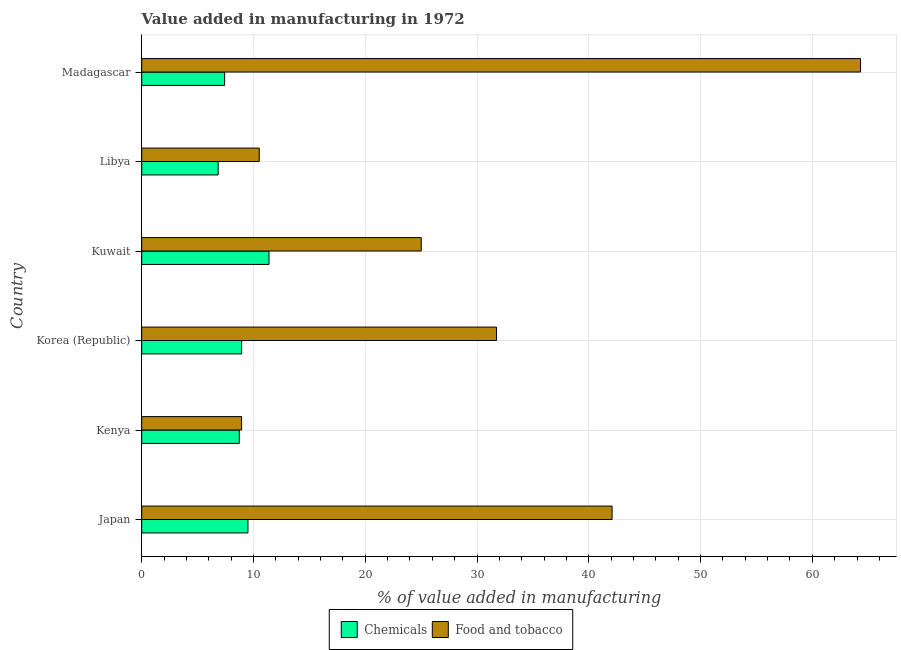How many different coloured bars are there?
Offer a very short reply. 2. How many bars are there on the 3rd tick from the top?
Keep it short and to the point. 2. What is the label of the 4th group of bars from the top?
Ensure brevity in your answer.  Korea (Republic). What is the value added by manufacturing food and tobacco in Kenya?
Keep it short and to the point. 8.94. Across all countries, what is the maximum value added by manufacturing food and tobacco?
Your response must be concise. 64.31. Across all countries, what is the minimum value added by  manufacturing chemicals?
Make the answer very short. 6.84. In which country was the value added by manufacturing food and tobacco maximum?
Ensure brevity in your answer.  Madagascar. In which country was the value added by  manufacturing chemicals minimum?
Offer a terse response. Libya. What is the total value added by manufacturing food and tobacco in the graph?
Provide a short and direct response. 182.6. What is the difference between the value added by manufacturing food and tobacco in Japan and that in Kuwait?
Keep it short and to the point. 17.07. What is the difference between the value added by  manufacturing chemicals in Libya and the value added by manufacturing food and tobacco in Korea (Republic)?
Ensure brevity in your answer.  -24.91. What is the average value added by manufacturing food and tobacco per country?
Keep it short and to the point. 30.43. What is the difference between the value added by manufacturing food and tobacco and value added by  manufacturing chemicals in Libya?
Provide a succinct answer. 3.68. In how many countries, is the value added by  manufacturing chemicals greater than 12 %?
Keep it short and to the point. 0. What is the ratio of the value added by  manufacturing chemicals in Japan to that in Korea (Republic)?
Offer a very short reply. 1.06. Is the difference between the value added by manufacturing food and tobacco in Korea (Republic) and Libya greater than the difference between the value added by  manufacturing chemicals in Korea (Republic) and Libya?
Give a very brief answer. Yes. What is the difference between the highest and the second highest value added by  manufacturing chemicals?
Ensure brevity in your answer.  1.88. What is the difference between the highest and the lowest value added by  manufacturing chemicals?
Provide a short and direct response. 4.55. In how many countries, is the value added by  manufacturing chemicals greater than the average value added by  manufacturing chemicals taken over all countries?
Make the answer very short. 3. What does the 1st bar from the top in Japan represents?
Offer a very short reply. Food and tobacco. What does the 1st bar from the bottom in Libya represents?
Offer a terse response. Chemicals. How many bars are there?
Your response must be concise. 12. How many countries are there in the graph?
Offer a terse response. 6. Are the values on the major ticks of X-axis written in scientific E-notation?
Keep it short and to the point. No. Does the graph contain any zero values?
Provide a succinct answer. No. What is the title of the graph?
Your response must be concise. Value added in manufacturing in 1972. Does "Nonresident" appear as one of the legend labels in the graph?
Keep it short and to the point. No. What is the label or title of the X-axis?
Your response must be concise. % of value added in manufacturing. What is the label or title of the Y-axis?
Make the answer very short. Country. What is the % of value added in manufacturing of Chemicals in Japan?
Your answer should be compact. 9.5. What is the % of value added in manufacturing of Food and tobacco in Japan?
Offer a very short reply. 42.08. What is the % of value added in manufacturing of Chemicals in Kenya?
Your answer should be very brief. 8.73. What is the % of value added in manufacturing of Food and tobacco in Kenya?
Give a very brief answer. 8.94. What is the % of value added in manufacturing in Chemicals in Korea (Republic)?
Provide a succinct answer. 8.94. What is the % of value added in manufacturing of Food and tobacco in Korea (Republic)?
Provide a succinct answer. 31.75. What is the % of value added in manufacturing in Chemicals in Kuwait?
Your answer should be compact. 11.39. What is the % of value added in manufacturing of Food and tobacco in Kuwait?
Offer a terse response. 25.01. What is the % of value added in manufacturing of Chemicals in Libya?
Offer a very short reply. 6.84. What is the % of value added in manufacturing of Food and tobacco in Libya?
Your answer should be compact. 10.51. What is the % of value added in manufacturing of Chemicals in Madagascar?
Provide a short and direct response. 7.42. What is the % of value added in manufacturing in Food and tobacco in Madagascar?
Offer a terse response. 64.31. Across all countries, what is the maximum % of value added in manufacturing in Chemicals?
Your answer should be compact. 11.39. Across all countries, what is the maximum % of value added in manufacturing in Food and tobacco?
Offer a terse response. 64.31. Across all countries, what is the minimum % of value added in manufacturing of Chemicals?
Offer a very short reply. 6.84. Across all countries, what is the minimum % of value added in manufacturing of Food and tobacco?
Keep it short and to the point. 8.94. What is the total % of value added in manufacturing of Chemicals in the graph?
Offer a terse response. 52.82. What is the total % of value added in manufacturing in Food and tobacco in the graph?
Give a very brief answer. 182.6. What is the difference between the % of value added in manufacturing of Chemicals in Japan and that in Kenya?
Keep it short and to the point. 0.77. What is the difference between the % of value added in manufacturing in Food and tobacco in Japan and that in Kenya?
Give a very brief answer. 33.15. What is the difference between the % of value added in manufacturing of Chemicals in Japan and that in Korea (Republic)?
Keep it short and to the point. 0.56. What is the difference between the % of value added in manufacturing in Food and tobacco in Japan and that in Korea (Republic)?
Provide a succinct answer. 10.34. What is the difference between the % of value added in manufacturing of Chemicals in Japan and that in Kuwait?
Ensure brevity in your answer.  -1.88. What is the difference between the % of value added in manufacturing in Food and tobacco in Japan and that in Kuwait?
Your answer should be very brief. 17.07. What is the difference between the % of value added in manufacturing of Chemicals in Japan and that in Libya?
Ensure brevity in your answer.  2.67. What is the difference between the % of value added in manufacturing of Food and tobacco in Japan and that in Libya?
Provide a succinct answer. 31.57. What is the difference between the % of value added in manufacturing in Chemicals in Japan and that in Madagascar?
Your answer should be very brief. 2.08. What is the difference between the % of value added in manufacturing in Food and tobacco in Japan and that in Madagascar?
Your answer should be very brief. -22.23. What is the difference between the % of value added in manufacturing of Chemicals in Kenya and that in Korea (Republic)?
Make the answer very short. -0.21. What is the difference between the % of value added in manufacturing in Food and tobacco in Kenya and that in Korea (Republic)?
Ensure brevity in your answer.  -22.81. What is the difference between the % of value added in manufacturing of Chemicals in Kenya and that in Kuwait?
Provide a short and direct response. -2.66. What is the difference between the % of value added in manufacturing in Food and tobacco in Kenya and that in Kuwait?
Offer a very short reply. -16.07. What is the difference between the % of value added in manufacturing in Chemicals in Kenya and that in Libya?
Provide a succinct answer. 1.89. What is the difference between the % of value added in manufacturing in Food and tobacco in Kenya and that in Libya?
Your answer should be very brief. -1.58. What is the difference between the % of value added in manufacturing in Chemicals in Kenya and that in Madagascar?
Your response must be concise. 1.31. What is the difference between the % of value added in manufacturing in Food and tobacco in Kenya and that in Madagascar?
Offer a very short reply. -55.38. What is the difference between the % of value added in manufacturing in Chemicals in Korea (Republic) and that in Kuwait?
Offer a terse response. -2.45. What is the difference between the % of value added in manufacturing of Food and tobacco in Korea (Republic) and that in Kuwait?
Your answer should be very brief. 6.74. What is the difference between the % of value added in manufacturing in Chemicals in Korea (Republic) and that in Libya?
Give a very brief answer. 2.1. What is the difference between the % of value added in manufacturing of Food and tobacco in Korea (Republic) and that in Libya?
Offer a terse response. 21.23. What is the difference between the % of value added in manufacturing in Chemicals in Korea (Republic) and that in Madagascar?
Keep it short and to the point. 1.52. What is the difference between the % of value added in manufacturing of Food and tobacco in Korea (Republic) and that in Madagascar?
Make the answer very short. -32.57. What is the difference between the % of value added in manufacturing of Chemicals in Kuwait and that in Libya?
Your answer should be compact. 4.55. What is the difference between the % of value added in manufacturing of Food and tobacco in Kuwait and that in Libya?
Make the answer very short. 14.49. What is the difference between the % of value added in manufacturing in Chemicals in Kuwait and that in Madagascar?
Ensure brevity in your answer.  3.97. What is the difference between the % of value added in manufacturing of Food and tobacco in Kuwait and that in Madagascar?
Your response must be concise. -39.3. What is the difference between the % of value added in manufacturing in Chemicals in Libya and that in Madagascar?
Provide a short and direct response. -0.58. What is the difference between the % of value added in manufacturing in Food and tobacco in Libya and that in Madagascar?
Make the answer very short. -53.8. What is the difference between the % of value added in manufacturing of Chemicals in Japan and the % of value added in manufacturing of Food and tobacco in Kenya?
Provide a short and direct response. 0.57. What is the difference between the % of value added in manufacturing in Chemicals in Japan and the % of value added in manufacturing in Food and tobacco in Korea (Republic)?
Ensure brevity in your answer.  -22.24. What is the difference between the % of value added in manufacturing of Chemicals in Japan and the % of value added in manufacturing of Food and tobacco in Kuwait?
Provide a succinct answer. -15.5. What is the difference between the % of value added in manufacturing of Chemicals in Japan and the % of value added in manufacturing of Food and tobacco in Libya?
Make the answer very short. -1.01. What is the difference between the % of value added in manufacturing in Chemicals in Japan and the % of value added in manufacturing in Food and tobacco in Madagascar?
Make the answer very short. -54.81. What is the difference between the % of value added in manufacturing of Chemicals in Kenya and the % of value added in manufacturing of Food and tobacco in Korea (Republic)?
Provide a succinct answer. -23.02. What is the difference between the % of value added in manufacturing in Chemicals in Kenya and the % of value added in manufacturing in Food and tobacco in Kuwait?
Provide a short and direct response. -16.28. What is the difference between the % of value added in manufacturing of Chemicals in Kenya and the % of value added in manufacturing of Food and tobacco in Libya?
Offer a terse response. -1.79. What is the difference between the % of value added in manufacturing in Chemicals in Kenya and the % of value added in manufacturing in Food and tobacco in Madagascar?
Your response must be concise. -55.58. What is the difference between the % of value added in manufacturing in Chemicals in Korea (Republic) and the % of value added in manufacturing in Food and tobacco in Kuwait?
Provide a short and direct response. -16.07. What is the difference between the % of value added in manufacturing in Chemicals in Korea (Republic) and the % of value added in manufacturing in Food and tobacco in Libya?
Provide a succinct answer. -1.57. What is the difference between the % of value added in manufacturing in Chemicals in Korea (Republic) and the % of value added in manufacturing in Food and tobacco in Madagascar?
Offer a terse response. -55.37. What is the difference between the % of value added in manufacturing in Chemicals in Kuwait and the % of value added in manufacturing in Food and tobacco in Libya?
Keep it short and to the point. 0.87. What is the difference between the % of value added in manufacturing in Chemicals in Kuwait and the % of value added in manufacturing in Food and tobacco in Madagascar?
Give a very brief answer. -52.93. What is the difference between the % of value added in manufacturing of Chemicals in Libya and the % of value added in manufacturing of Food and tobacco in Madagascar?
Your answer should be compact. -57.47. What is the average % of value added in manufacturing in Chemicals per country?
Offer a terse response. 8.8. What is the average % of value added in manufacturing of Food and tobacco per country?
Keep it short and to the point. 30.43. What is the difference between the % of value added in manufacturing in Chemicals and % of value added in manufacturing in Food and tobacco in Japan?
Offer a terse response. -32.58. What is the difference between the % of value added in manufacturing of Chemicals and % of value added in manufacturing of Food and tobacco in Kenya?
Offer a very short reply. -0.21. What is the difference between the % of value added in manufacturing of Chemicals and % of value added in manufacturing of Food and tobacco in Korea (Republic)?
Your response must be concise. -22.8. What is the difference between the % of value added in manufacturing of Chemicals and % of value added in manufacturing of Food and tobacco in Kuwait?
Your response must be concise. -13.62. What is the difference between the % of value added in manufacturing of Chemicals and % of value added in manufacturing of Food and tobacco in Libya?
Provide a short and direct response. -3.68. What is the difference between the % of value added in manufacturing of Chemicals and % of value added in manufacturing of Food and tobacco in Madagascar?
Your answer should be compact. -56.89. What is the ratio of the % of value added in manufacturing in Chemicals in Japan to that in Kenya?
Offer a very short reply. 1.09. What is the ratio of the % of value added in manufacturing in Food and tobacco in Japan to that in Kenya?
Offer a very short reply. 4.71. What is the ratio of the % of value added in manufacturing of Chemicals in Japan to that in Korea (Republic)?
Your answer should be compact. 1.06. What is the ratio of the % of value added in manufacturing of Food and tobacco in Japan to that in Korea (Republic)?
Provide a short and direct response. 1.33. What is the ratio of the % of value added in manufacturing in Chemicals in Japan to that in Kuwait?
Provide a succinct answer. 0.83. What is the ratio of the % of value added in manufacturing in Food and tobacco in Japan to that in Kuwait?
Make the answer very short. 1.68. What is the ratio of the % of value added in manufacturing in Chemicals in Japan to that in Libya?
Your answer should be compact. 1.39. What is the ratio of the % of value added in manufacturing in Food and tobacco in Japan to that in Libya?
Provide a succinct answer. 4. What is the ratio of the % of value added in manufacturing of Chemicals in Japan to that in Madagascar?
Make the answer very short. 1.28. What is the ratio of the % of value added in manufacturing in Food and tobacco in Japan to that in Madagascar?
Provide a short and direct response. 0.65. What is the ratio of the % of value added in manufacturing of Chemicals in Kenya to that in Korea (Republic)?
Offer a terse response. 0.98. What is the ratio of the % of value added in manufacturing of Food and tobacco in Kenya to that in Korea (Republic)?
Provide a short and direct response. 0.28. What is the ratio of the % of value added in manufacturing in Chemicals in Kenya to that in Kuwait?
Provide a succinct answer. 0.77. What is the ratio of the % of value added in manufacturing of Food and tobacco in Kenya to that in Kuwait?
Provide a succinct answer. 0.36. What is the ratio of the % of value added in manufacturing in Chemicals in Kenya to that in Libya?
Give a very brief answer. 1.28. What is the ratio of the % of value added in manufacturing of Food and tobacco in Kenya to that in Libya?
Your answer should be compact. 0.85. What is the ratio of the % of value added in manufacturing of Chemicals in Kenya to that in Madagascar?
Your answer should be compact. 1.18. What is the ratio of the % of value added in manufacturing in Food and tobacco in Kenya to that in Madagascar?
Your answer should be compact. 0.14. What is the ratio of the % of value added in manufacturing in Chemicals in Korea (Republic) to that in Kuwait?
Give a very brief answer. 0.79. What is the ratio of the % of value added in manufacturing in Food and tobacco in Korea (Republic) to that in Kuwait?
Your answer should be very brief. 1.27. What is the ratio of the % of value added in manufacturing in Chemicals in Korea (Republic) to that in Libya?
Your response must be concise. 1.31. What is the ratio of the % of value added in manufacturing in Food and tobacco in Korea (Republic) to that in Libya?
Your response must be concise. 3.02. What is the ratio of the % of value added in manufacturing of Chemicals in Korea (Republic) to that in Madagascar?
Your answer should be very brief. 1.21. What is the ratio of the % of value added in manufacturing of Food and tobacco in Korea (Republic) to that in Madagascar?
Your response must be concise. 0.49. What is the ratio of the % of value added in manufacturing in Chemicals in Kuwait to that in Libya?
Your answer should be compact. 1.67. What is the ratio of the % of value added in manufacturing of Food and tobacco in Kuwait to that in Libya?
Ensure brevity in your answer.  2.38. What is the ratio of the % of value added in manufacturing in Chemicals in Kuwait to that in Madagascar?
Keep it short and to the point. 1.53. What is the ratio of the % of value added in manufacturing of Food and tobacco in Kuwait to that in Madagascar?
Provide a short and direct response. 0.39. What is the ratio of the % of value added in manufacturing of Chemicals in Libya to that in Madagascar?
Give a very brief answer. 0.92. What is the ratio of the % of value added in manufacturing of Food and tobacco in Libya to that in Madagascar?
Ensure brevity in your answer.  0.16. What is the difference between the highest and the second highest % of value added in manufacturing in Chemicals?
Offer a very short reply. 1.88. What is the difference between the highest and the second highest % of value added in manufacturing of Food and tobacco?
Your answer should be compact. 22.23. What is the difference between the highest and the lowest % of value added in manufacturing in Chemicals?
Provide a succinct answer. 4.55. What is the difference between the highest and the lowest % of value added in manufacturing in Food and tobacco?
Offer a terse response. 55.38. 